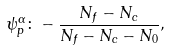<formula> <loc_0><loc_0><loc_500><loc_500>\psi _ { p } ^ { \alpha } \colon - \frac { N _ { f } - N _ { c } } { N _ { f } - N _ { c } - N _ { 0 } } ,</formula> 